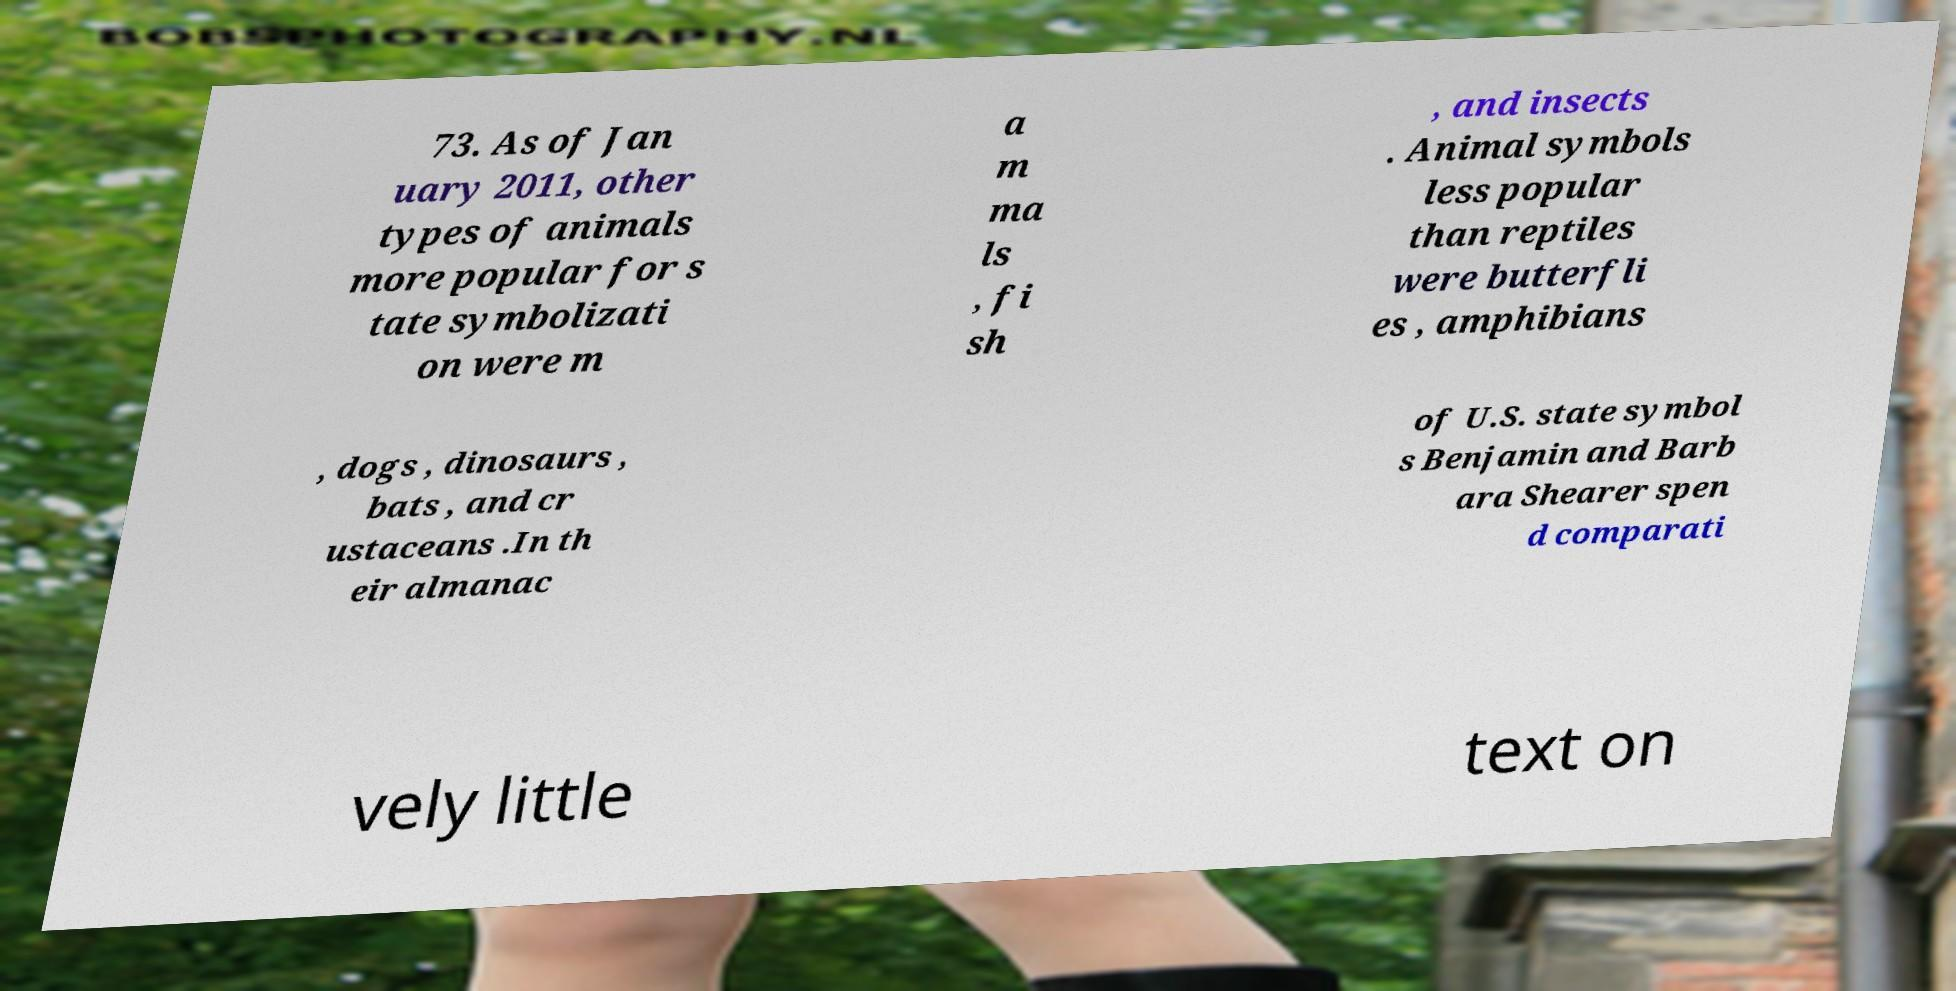Could you extract and type out the text from this image? 73. As of Jan uary 2011, other types of animals more popular for s tate symbolizati on were m a m ma ls , fi sh , and insects . Animal symbols less popular than reptiles were butterfli es , amphibians , dogs , dinosaurs , bats , and cr ustaceans .In th eir almanac of U.S. state symbol s Benjamin and Barb ara Shearer spen d comparati vely little text on 